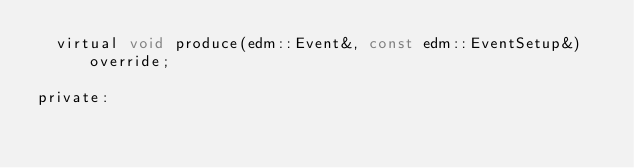<code> <loc_0><loc_0><loc_500><loc_500><_C_>  virtual void produce(edm::Event&, const edm::EventSetup&) override;

private:
  </code> 